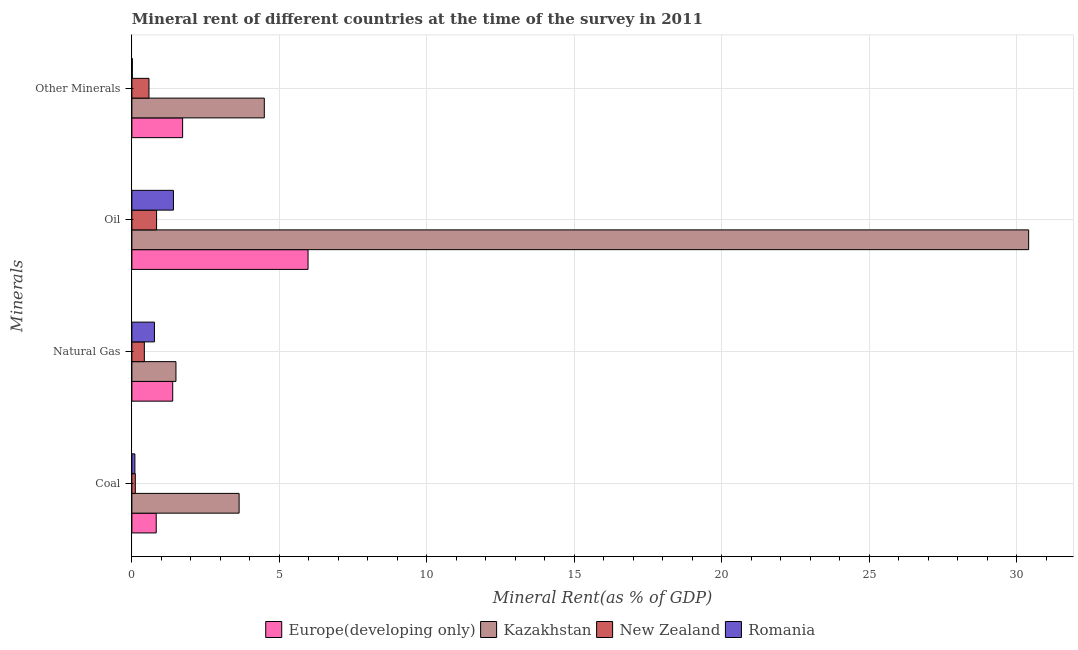How many groups of bars are there?
Keep it short and to the point. 4. Are the number of bars per tick equal to the number of legend labels?
Your answer should be very brief. Yes. Are the number of bars on each tick of the Y-axis equal?
Offer a very short reply. Yes. What is the label of the 4th group of bars from the top?
Ensure brevity in your answer.  Coal. What is the oil rent in Kazakhstan?
Keep it short and to the point. 30.4. Across all countries, what is the maximum coal rent?
Your answer should be compact. 3.64. Across all countries, what is the minimum coal rent?
Offer a terse response. 0.1. In which country was the natural gas rent maximum?
Offer a very short reply. Kazakhstan. In which country was the natural gas rent minimum?
Give a very brief answer. New Zealand. What is the total coal rent in the graph?
Offer a terse response. 4.68. What is the difference between the natural gas rent in Kazakhstan and that in Romania?
Keep it short and to the point. 0.73. What is the difference between the oil rent in Kazakhstan and the  rent of other minerals in Romania?
Give a very brief answer. 30.39. What is the average coal rent per country?
Your answer should be very brief. 1.17. What is the difference between the natural gas rent and coal rent in Europe(developing only)?
Your answer should be very brief. 0.56. In how many countries, is the coal rent greater than 29 %?
Ensure brevity in your answer.  0. What is the ratio of the oil rent in Romania to that in New Zealand?
Provide a short and direct response. 1.68. Is the difference between the coal rent in Europe(developing only) and Romania greater than the difference between the natural gas rent in Europe(developing only) and Romania?
Provide a succinct answer. Yes. What is the difference between the highest and the second highest coal rent?
Keep it short and to the point. 2.81. What is the difference between the highest and the lowest natural gas rent?
Make the answer very short. 1.07. In how many countries, is the coal rent greater than the average coal rent taken over all countries?
Give a very brief answer. 1. Is it the case that in every country, the sum of the oil rent and coal rent is greater than the sum of  rent of other minerals and natural gas rent?
Ensure brevity in your answer.  No. What does the 2nd bar from the top in Coal represents?
Ensure brevity in your answer.  New Zealand. What does the 3rd bar from the bottom in Coal represents?
Provide a succinct answer. New Zealand. Is it the case that in every country, the sum of the coal rent and natural gas rent is greater than the oil rent?
Keep it short and to the point. No. Are all the bars in the graph horizontal?
Provide a succinct answer. Yes. What is the difference between two consecutive major ticks on the X-axis?
Ensure brevity in your answer.  5. Does the graph contain any zero values?
Keep it short and to the point. No. Does the graph contain grids?
Your answer should be compact. Yes. Where does the legend appear in the graph?
Provide a short and direct response. Bottom center. What is the title of the graph?
Provide a succinct answer. Mineral rent of different countries at the time of the survey in 2011. What is the label or title of the X-axis?
Keep it short and to the point. Mineral Rent(as % of GDP). What is the label or title of the Y-axis?
Your answer should be very brief. Minerals. What is the Mineral Rent(as % of GDP) of Europe(developing only) in Coal?
Your answer should be compact. 0.83. What is the Mineral Rent(as % of GDP) in Kazakhstan in Coal?
Keep it short and to the point. 3.64. What is the Mineral Rent(as % of GDP) of New Zealand in Coal?
Offer a very short reply. 0.12. What is the Mineral Rent(as % of GDP) in Romania in Coal?
Ensure brevity in your answer.  0.1. What is the Mineral Rent(as % of GDP) of Europe(developing only) in Natural Gas?
Keep it short and to the point. 1.38. What is the Mineral Rent(as % of GDP) of Kazakhstan in Natural Gas?
Make the answer very short. 1.49. What is the Mineral Rent(as % of GDP) in New Zealand in Natural Gas?
Offer a terse response. 0.42. What is the Mineral Rent(as % of GDP) in Romania in Natural Gas?
Keep it short and to the point. 0.76. What is the Mineral Rent(as % of GDP) in Europe(developing only) in Oil?
Your answer should be compact. 5.97. What is the Mineral Rent(as % of GDP) of Kazakhstan in Oil?
Make the answer very short. 30.4. What is the Mineral Rent(as % of GDP) in New Zealand in Oil?
Keep it short and to the point. 0.84. What is the Mineral Rent(as % of GDP) of Romania in Oil?
Ensure brevity in your answer.  1.41. What is the Mineral Rent(as % of GDP) in Europe(developing only) in Other Minerals?
Offer a very short reply. 1.72. What is the Mineral Rent(as % of GDP) of Kazakhstan in Other Minerals?
Offer a terse response. 4.49. What is the Mineral Rent(as % of GDP) of New Zealand in Other Minerals?
Offer a very short reply. 0.58. What is the Mineral Rent(as % of GDP) in Romania in Other Minerals?
Ensure brevity in your answer.  0.02. Across all Minerals, what is the maximum Mineral Rent(as % of GDP) of Europe(developing only)?
Provide a succinct answer. 5.97. Across all Minerals, what is the maximum Mineral Rent(as % of GDP) in Kazakhstan?
Make the answer very short. 30.4. Across all Minerals, what is the maximum Mineral Rent(as % of GDP) of New Zealand?
Provide a succinct answer. 0.84. Across all Minerals, what is the maximum Mineral Rent(as % of GDP) in Romania?
Provide a short and direct response. 1.41. Across all Minerals, what is the minimum Mineral Rent(as % of GDP) of Europe(developing only)?
Provide a succinct answer. 0.83. Across all Minerals, what is the minimum Mineral Rent(as % of GDP) in Kazakhstan?
Your answer should be very brief. 1.49. Across all Minerals, what is the minimum Mineral Rent(as % of GDP) of New Zealand?
Ensure brevity in your answer.  0.12. Across all Minerals, what is the minimum Mineral Rent(as % of GDP) of Romania?
Your response must be concise. 0.02. What is the total Mineral Rent(as % of GDP) of Europe(developing only) in the graph?
Your response must be concise. 9.9. What is the total Mineral Rent(as % of GDP) in Kazakhstan in the graph?
Your answer should be very brief. 40.02. What is the total Mineral Rent(as % of GDP) in New Zealand in the graph?
Offer a very short reply. 1.96. What is the total Mineral Rent(as % of GDP) in Romania in the graph?
Provide a succinct answer. 2.29. What is the difference between the Mineral Rent(as % of GDP) in Europe(developing only) in Coal and that in Natural Gas?
Your response must be concise. -0.56. What is the difference between the Mineral Rent(as % of GDP) of Kazakhstan in Coal and that in Natural Gas?
Provide a succinct answer. 2.14. What is the difference between the Mineral Rent(as % of GDP) of New Zealand in Coal and that in Natural Gas?
Provide a succinct answer. -0.31. What is the difference between the Mineral Rent(as % of GDP) in Romania in Coal and that in Natural Gas?
Your response must be concise. -0.66. What is the difference between the Mineral Rent(as % of GDP) in Europe(developing only) in Coal and that in Oil?
Ensure brevity in your answer.  -5.15. What is the difference between the Mineral Rent(as % of GDP) in Kazakhstan in Coal and that in Oil?
Your response must be concise. -26.77. What is the difference between the Mineral Rent(as % of GDP) in New Zealand in Coal and that in Oil?
Ensure brevity in your answer.  -0.72. What is the difference between the Mineral Rent(as % of GDP) in Romania in Coal and that in Oil?
Keep it short and to the point. -1.31. What is the difference between the Mineral Rent(as % of GDP) of Europe(developing only) in Coal and that in Other Minerals?
Provide a succinct answer. -0.9. What is the difference between the Mineral Rent(as % of GDP) in Kazakhstan in Coal and that in Other Minerals?
Provide a short and direct response. -0.85. What is the difference between the Mineral Rent(as % of GDP) of New Zealand in Coal and that in Other Minerals?
Ensure brevity in your answer.  -0.46. What is the difference between the Mineral Rent(as % of GDP) of Romania in Coal and that in Other Minerals?
Give a very brief answer. 0.09. What is the difference between the Mineral Rent(as % of GDP) of Europe(developing only) in Natural Gas and that in Oil?
Give a very brief answer. -4.59. What is the difference between the Mineral Rent(as % of GDP) of Kazakhstan in Natural Gas and that in Oil?
Ensure brevity in your answer.  -28.91. What is the difference between the Mineral Rent(as % of GDP) in New Zealand in Natural Gas and that in Oil?
Give a very brief answer. -0.42. What is the difference between the Mineral Rent(as % of GDP) of Romania in Natural Gas and that in Oil?
Ensure brevity in your answer.  -0.64. What is the difference between the Mineral Rent(as % of GDP) in Europe(developing only) in Natural Gas and that in Other Minerals?
Offer a terse response. -0.34. What is the difference between the Mineral Rent(as % of GDP) of Kazakhstan in Natural Gas and that in Other Minerals?
Keep it short and to the point. -3. What is the difference between the Mineral Rent(as % of GDP) in New Zealand in Natural Gas and that in Other Minerals?
Make the answer very short. -0.16. What is the difference between the Mineral Rent(as % of GDP) in Romania in Natural Gas and that in Other Minerals?
Make the answer very short. 0.75. What is the difference between the Mineral Rent(as % of GDP) in Europe(developing only) in Oil and that in Other Minerals?
Offer a terse response. 4.25. What is the difference between the Mineral Rent(as % of GDP) in Kazakhstan in Oil and that in Other Minerals?
Your answer should be compact. 25.91. What is the difference between the Mineral Rent(as % of GDP) in New Zealand in Oil and that in Other Minerals?
Make the answer very short. 0.26. What is the difference between the Mineral Rent(as % of GDP) of Romania in Oil and that in Other Minerals?
Keep it short and to the point. 1.39. What is the difference between the Mineral Rent(as % of GDP) of Europe(developing only) in Coal and the Mineral Rent(as % of GDP) of Kazakhstan in Natural Gas?
Make the answer very short. -0.67. What is the difference between the Mineral Rent(as % of GDP) in Europe(developing only) in Coal and the Mineral Rent(as % of GDP) in New Zealand in Natural Gas?
Your answer should be very brief. 0.4. What is the difference between the Mineral Rent(as % of GDP) of Europe(developing only) in Coal and the Mineral Rent(as % of GDP) of Romania in Natural Gas?
Give a very brief answer. 0.06. What is the difference between the Mineral Rent(as % of GDP) of Kazakhstan in Coal and the Mineral Rent(as % of GDP) of New Zealand in Natural Gas?
Make the answer very short. 3.21. What is the difference between the Mineral Rent(as % of GDP) in Kazakhstan in Coal and the Mineral Rent(as % of GDP) in Romania in Natural Gas?
Give a very brief answer. 2.87. What is the difference between the Mineral Rent(as % of GDP) in New Zealand in Coal and the Mineral Rent(as % of GDP) in Romania in Natural Gas?
Provide a succinct answer. -0.65. What is the difference between the Mineral Rent(as % of GDP) in Europe(developing only) in Coal and the Mineral Rent(as % of GDP) in Kazakhstan in Oil?
Ensure brevity in your answer.  -29.58. What is the difference between the Mineral Rent(as % of GDP) of Europe(developing only) in Coal and the Mineral Rent(as % of GDP) of New Zealand in Oil?
Provide a succinct answer. -0.01. What is the difference between the Mineral Rent(as % of GDP) in Europe(developing only) in Coal and the Mineral Rent(as % of GDP) in Romania in Oil?
Give a very brief answer. -0.58. What is the difference between the Mineral Rent(as % of GDP) of Kazakhstan in Coal and the Mineral Rent(as % of GDP) of New Zealand in Oil?
Your response must be concise. 2.8. What is the difference between the Mineral Rent(as % of GDP) in Kazakhstan in Coal and the Mineral Rent(as % of GDP) in Romania in Oil?
Give a very brief answer. 2.23. What is the difference between the Mineral Rent(as % of GDP) in New Zealand in Coal and the Mineral Rent(as % of GDP) in Romania in Oil?
Keep it short and to the point. -1.29. What is the difference between the Mineral Rent(as % of GDP) of Europe(developing only) in Coal and the Mineral Rent(as % of GDP) of Kazakhstan in Other Minerals?
Offer a terse response. -3.66. What is the difference between the Mineral Rent(as % of GDP) in Europe(developing only) in Coal and the Mineral Rent(as % of GDP) in New Zealand in Other Minerals?
Keep it short and to the point. 0.25. What is the difference between the Mineral Rent(as % of GDP) of Europe(developing only) in Coal and the Mineral Rent(as % of GDP) of Romania in Other Minerals?
Give a very brief answer. 0.81. What is the difference between the Mineral Rent(as % of GDP) in Kazakhstan in Coal and the Mineral Rent(as % of GDP) in New Zealand in Other Minerals?
Ensure brevity in your answer.  3.06. What is the difference between the Mineral Rent(as % of GDP) of Kazakhstan in Coal and the Mineral Rent(as % of GDP) of Romania in Other Minerals?
Provide a short and direct response. 3.62. What is the difference between the Mineral Rent(as % of GDP) in New Zealand in Coal and the Mineral Rent(as % of GDP) in Romania in Other Minerals?
Your answer should be compact. 0.1. What is the difference between the Mineral Rent(as % of GDP) of Europe(developing only) in Natural Gas and the Mineral Rent(as % of GDP) of Kazakhstan in Oil?
Make the answer very short. -29.02. What is the difference between the Mineral Rent(as % of GDP) in Europe(developing only) in Natural Gas and the Mineral Rent(as % of GDP) in New Zealand in Oil?
Provide a succinct answer. 0.55. What is the difference between the Mineral Rent(as % of GDP) of Europe(developing only) in Natural Gas and the Mineral Rent(as % of GDP) of Romania in Oil?
Your answer should be compact. -0.02. What is the difference between the Mineral Rent(as % of GDP) in Kazakhstan in Natural Gas and the Mineral Rent(as % of GDP) in New Zealand in Oil?
Make the answer very short. 0.66. What is the difference between the Mineral Rent(as % of GDP) in Kazakhstan in Natural Gas and the Mineral Rent(as % of GDP) in Romania in Oil?
Your answer should be very brief. 0.09. What is the difference between the Mineral Rent(as % of GDP) of New Zealand in Natural Gas and the Mineral Rent(as % of GDP) of Romania in Oil?
Your answer should be very brief. -0.99. What is the difference between the Mineral Rent(as % of GDP) of Europe(developing only) in Natural Gas and the Mineral Rent(as % of GDP) of Kazakhstan in Other Minerals?
Make the answer very short. -3.1. What is the difference between the Mineral Rent(as % of GDP) of Europe(developing only) in Natural Gas and the Mineral Rent(as % of GDP) of New Zealand in Other Minerals?
Offer a very short reply. 0.8. What is the difference between the Mineral Rent(as % of GDP) of Europe(developing only) in Natural Gas and the Mineral Rent(as % of GDP) of Romania in Other Minerals?
Provide a short and direct response. 1.37. What is the difference between the Mineral Rent(as % of GDP) of Kazakhstan in Natural Gas and the Mineral Rent(as % of GDP) of New Zealand in Other Minerals?
Your answer should be very brief. 0.91. What is the difference between the Mineral Rent(as % of GDP) in Kazakhstan in Natural Gas and the Mineral Rent(as % of GDP) in Romania in Other Minerals?
Your answer should be very brief. 1.48. What is the difference between the Mineral Rent(as % of GDP) of New Zealand in Natural Gas and the Mineral Rent(as % of GDP) of Romania in Other Minerals?
Keep it short and to the point. 0.41. What is the difference between the Mineral Rent(as % of GDP) in Europe(developing only) in Oil and the Mineral Rent(as % of GDP) in Kazakhstan in Other Minerals?
Give a very brief answer. 1.48. What is the difference between the Mineral Rent(as % of GDP) of Europe(developing only) in Oil and the Mineral Rent(as % of GDP) of New Zealand in Other Minerals?
Provide a succinct answer. 5.39. What is the difference between the Mineral Rent(as % of GDP) of Europe(developing only) in Oil and the Mineral Rent(as % of GDP) of Romania in Other Minerals?
Ensure brevity in your answer.  5.96. What is the difference between the Mineral Rent(as % of GDP) of Kazakhstan in Oil and the Mineral Rent(as % of GDP) of New Zealand in Other Minerals?
Offer a very short reply. 29.82. What is the difference between the Mineral Rent(as % of GDP) in Kazakhstan in Oil and the Mineral Rent(as % of GDP) in Romania in Other Minerals?
Keep it short and to the point. 30.39. What is the difference between the Mineral Rent(as % of GDP) of New Zealand in Oil and the Mineral Rent(as % of GDP) of Romania in Other Minerals?
Make the answer very short. 0.82. What is the average Mineral Rent(as % of GDP) in Europe(developing only) per Minerals?
Your answer should be very brief. 2.48. What is the average Mineral Rent(as % of GDP) of Kazakhstan per Minerals?
Offer a terse response. 10.01. What is the average Mineral Rent(as % of GDP) of New Zealand per Minerals?
Offer a very short reply. 0.49. What is the average Mineral Rent(as % of GDP) in Romania per Minerals?
Make the answer very short. 0.57. What is the difference between the Mineral Rent(as % of GDP) in Europe(developing only) and Mineral Rent(as % of GDP) in Kazakhstan in Coal?
Give a very brief answer. -2.81. What is the difference between the Mineral Rent(as % of GDP) of Europe(developing only) and Mineral Rent(as % of GDP) of New Zealand in Coal?
Keep it short and to the point. 0.71. What is the difference between the Mineral Rent(as % of GDP) in Europe(developing only) and Mineral Rent(as % of GDP) in Romania in Coal?
Provide a short and direct response. 0.72. What is the difference between the Mineral Rent(as % of GDP) in Kazakhstan and Mineral Rent(as % of GDP) in New Zealand in Coal?
Ensure brevity in your answer.  3.52. What is the difference between the Mineral Rent(as % of GDP) of Kazakhstan and Mineral Rent(as % of GDP) of Romania in Coal?
Provide a succinct answer. 3.53. What is the difference between the Mineral Rent(as % of GDP) in New Zealand and Mineral Rent(as % of GDP) in Romania in Coal?
Your response must be concise. 0.01. What is the difference between the Mineral Rent(as % of GDP) of Europe(developing only) and Mineral Rent(as % of GDP) of Kazakhstan in Natural Gas?
Your answer should be very brief. -0.11. What is the difference between the Mineral Rent(as % of GDP) of Europe(developing only) and Mineral Rent(as % of GDP) of New Zealand in Natural Gas?
Your answer should be compact. 0.96. What is the difference between the Mineral Rent(as % of GDP) of Europe(developing only) and Mineral Rent(as % of GDP) of Romania in Natural Gas?
Keep it short and to the point. 0.62. What is the difference between the Mineral Rent(as % of GDP) of Kazakhstan and Mineral Rent(as % of GDP) of New Zealand in Natural Gas?
Make the answer very short. 1.07. What is the difference between the Mineral Rent(as % of GDP) in Kazakhstan and Mineral Rent(as % of GDP) in Romania in Natural Gas?
Ensure brevity in your answer.  0.73. What is the difference between the Mineral Rent(as % of GDP) of New Zealand and Mineral Rent(as % of GDP) of Romania in Natural Gas?
Give a very brief answer. -0.34. What is the difference between the Mineral Rent(as % of GDP) of Europe(developing only) and Mineral Rent(as % of GDP) of Kazakhstan in Oil?
Offer a terse response. -24.43. What is the difference between the Mineral Rent(as % of GDP) of Europe(developing only) and Mineral Rent(as % of GDP) of New Zealand in Oil?
Provide a succinct answer. 5.13. What is the difference between the Mineral Rent(as % of GDP) in Europe(developing only) and Mineral Rent(as % of GDP) in Romania in Oil?
Provide a short and direct response. 4.56. What is the difference between the Mineral Rent(as % of GDP) in Kazakhstan and Mineral Rent(as % of GDP) in New Zealand in Oil?
Give a very brief answer. 29.56. What is the difference between the Mineral Rent(as % of GDP) in Kazakhstan and Mineral Rent(as % of GDP) in Romania in Oil?
Provide a short and direct response. 28.99. What is the difference between the Mineral Rent(as % of GDP) of New Zealand and Mineral Rent(as % of GDP) of Romania in Oil?
Give a very brief answer. -0.57. What is the difference between the Mineral Rent(as % of GDP) in Europe(developing only) and Mineral Rent(as % of GDP) in Kazakhstan in Other Minerals?
Give a very brief answer. -2.77. What is the difference between the Mineral Rent(as % of GDP) of Europe(developing only) and Mineral Rent(as % of GDP) of New Zealand in Other Minerals?
Provide a short and direct response. 1.14. What is the difference between the Mineral Rent(as % of GDP) in Europe(developing only) and Mineral Rent(as % of GDP) in Romania in Other Minerals?
Your answer should be compact. 1.7. What is the difference between the Mineral Rent(as % of GDP) in Kazakhstan and Mineral Rent(as % of GDP) in New Zealand in Other Minerals?
Ensure brevity in your answer.  3.91. What is the difference between the Mineral Rent(as % of GDP) of Kazakhstan and Mineral Rent(as % of GDP) of Romania in Other Minerals?
Your response must be concise. 4.47. What is the difference between the Mineral Rent(as % of GDP) of New Zealand and Mineral Rent(as % of GDP) of Romania in Other Minerals?
Ensure brevity in your answer.  0.56. What is the ratio of the Mineral Rent(as % of GDP) in Europe(developing only) in Coal to that in Natural Gas?
Offer a terse response. 0.6. What is the ratio of the Mineral Rent(as % of GDP) of Kazakhstan in Coal to that in Natural Gas?
Provide a succinct answer. 2.43. What is the ratio of the Mineral Rent(as % of GDP) of New Zealand in Coal to that in Natural Gas?
Keep it short and to the point. 0.28. What is the ratio of the Mineral Rent(as % of GDP) in Romania in Coal to that in Natural Gas?
Give a very brief answer. 0.13. What is the ratio of the Mineral Rent(as % of GDP) of Europe(developing only) in Coal to that in Oil?
Your response must be concise. 0.14. What is the ratio of the Mineral Rent(as % of GDP) in Kazakhstan in Coal to that in Oil?
Offer a very short reply. 0.12. What is the ratio of the Mineral Rent(as % of GDP) in New Zealand in Coal to that in Oil?
Ensure brevity in your answer.  0.14. What is the ratio of the Mineral Rent(as % of GDP) in Romania in Coal to that in Oil?
Ensure brevity in your answer.  0.07. What is the ratio of the Mineral Rent(as % of GDP) in Europe(developing only) in Coal to that in Other Minerals?
Your response must be concise. 0.48. What is the ratio of the Mineral Rent(as % of GDP) in Kazakhstan in Coal to that in Other Minerals?
Offer a terse response. 0.81. What is the ratio of the Mineral Rent(as % of GDP) of New Zealand in Coal to that in Other Minerals?
Make the answer very short. 0.2. What is the ratio of the Mineral Rent(as % of GDP) in Romania in Coal to that in Other Minerals?
Offer a very short reply. 6.59. What is the ratio of the Mineral Rent(as % of GDP) of Europe(developing only) in Natural Gas to that in Oil?
Your response must be concise. 0.23. What is the ratio of the Mineral Rent(as % of GDP) in Kazakhstan in Natural Gas to that in Oil?
Ensure brevity in your answer.  0.05. What is the ratio of the Mineral Rent(as % of GDP) of New Zealand in Natural Gas to that in Oil?
Ensure brevity in your answer.  0.5. What is the ratio of the Mineral Rent(as % of GDP) in Romania in Natural Gas to that in Oil?
Ensure brevity in your answer.  0.54. What is the ratio of the Mineral Rent(as % of GDP) of Europe(developing only) in Natural Gas to that in Other Minerals?
Offer a terse response. 0.8. What is the ratio of the Mineral Rent(as % of GDP) in Kazakhstan in Natural Gas to that in Other Minerals?
Keep it short and to the point. 0.33. What is the ratio of the Mineral Rent(as % of GDP) in New Zealand in Natural Gas to that in Other Minerals?
Keep it short and to the point. 0.73. What is the ratio of the Mineral Rent(as % of GDP) of Romania in Natural Gas to that in Other Minerals?
Make the answer very short. 49.17. What is the ratio of the Mineral Rent(as % of GDP) of Europe(developing only) in Oil to that in Other Minerals?
Offer a very short reply. 3.47. What is the ratio of the Mineral Rent(as % of GDP) in Kazakhstan in Oil to that in Other Minerals?
Make the answer very short. 6.77. What is the ratio of the Mineral Rent(as % of GDP) of New Zealand in Oil to that in Other Minerals?
Keep it short and to the point. 1.44. What is the ratio of the Mineral Rent(as % of GDP) of Romania in Oil to that in Other Minerals?
Provide a succinct answer. 90.59. What is the difference between the highest and the second highest Mineral Rent(as % of GDP) in Europe(developing only)?
Your answer should be very brief. 4.25. What is the difference between the highest and the second highest Mineral Rent(as % of GDP) in Kazakhstan?
Keep it short and to the point. 25.91. What is the difference between the highest and the second highest Mineral Rent(as % of GDP) in New Zealand?
Ensure brevity in your answer.  0.26. What is the difference between the highest and the second highest Mineral Rent(as % of GDP) in Romania?
Offer a terse response. 0.64. What is the difference between the highest and the lowest Mineral Rent(as % of GDP) in Europe(developing only)?
Make the answer very short. 5.15. What is the difference between the highest and the lowest Mineral Rent(as % of GDP) in Kazakhstan?
Offer a terse response. 28.91. What is the difference between the highest and the lowest Mineral Rent(as % of GDP) of New Zealand?
Keep it short and to the point. 0.72. What is the difference between the highest and the lowest Mineral Rent(as % of GDP) in Romania?
Your answer should be compact. 1.39. 